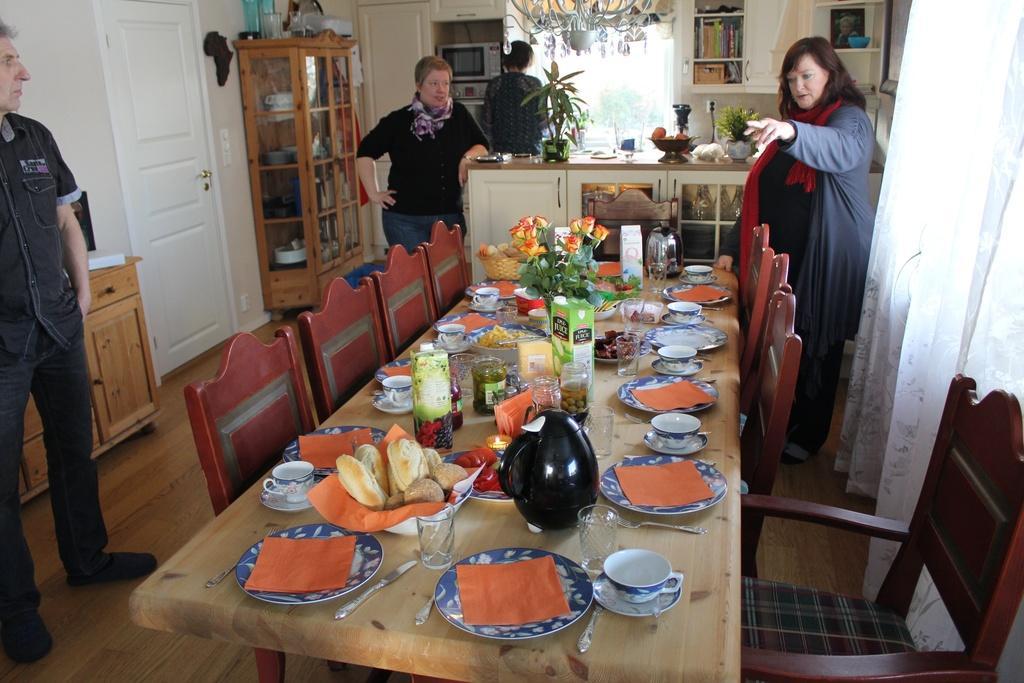Could you give a brief overview of what you see in this image? In this Image I see a man, 2 women and a person over here and I see that all of them are standing. I see there are chairs and table in front and there are lot of things on it. In the background I see the door, a cabinet, few things on the countertop and few things over here and I see 2 plants. 